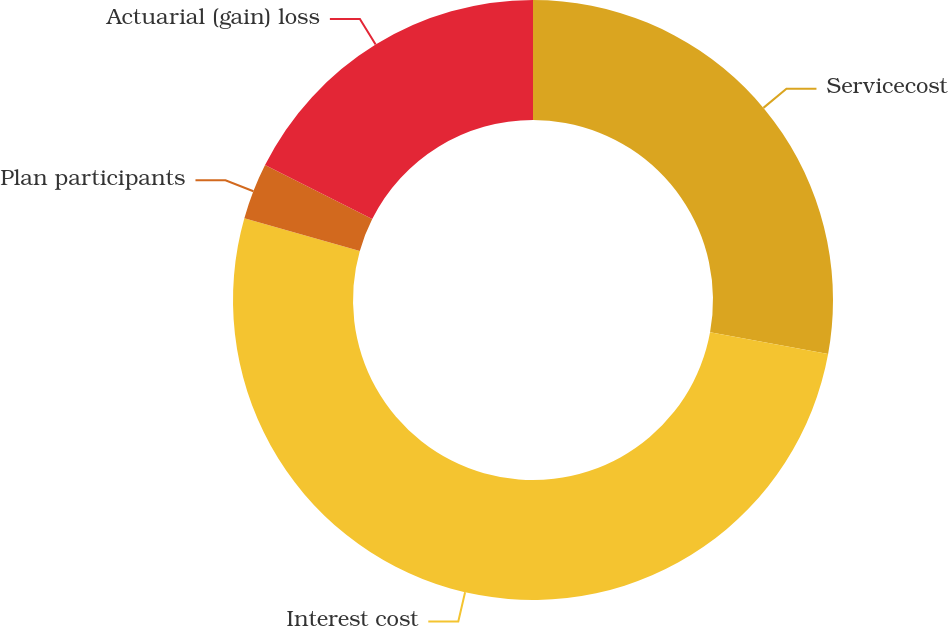<chart> <loc_0><loc_0><loc_500><loc_500><pie_chart><fcel>Servicecost<fcel>Interest cost<fcel>Plan participants<fcel>Actuarial (gain) loss<nl><fcel>27.88%<fcel>51.52%<fcel>3.03%<fcel>17.58%<nl></chart> 